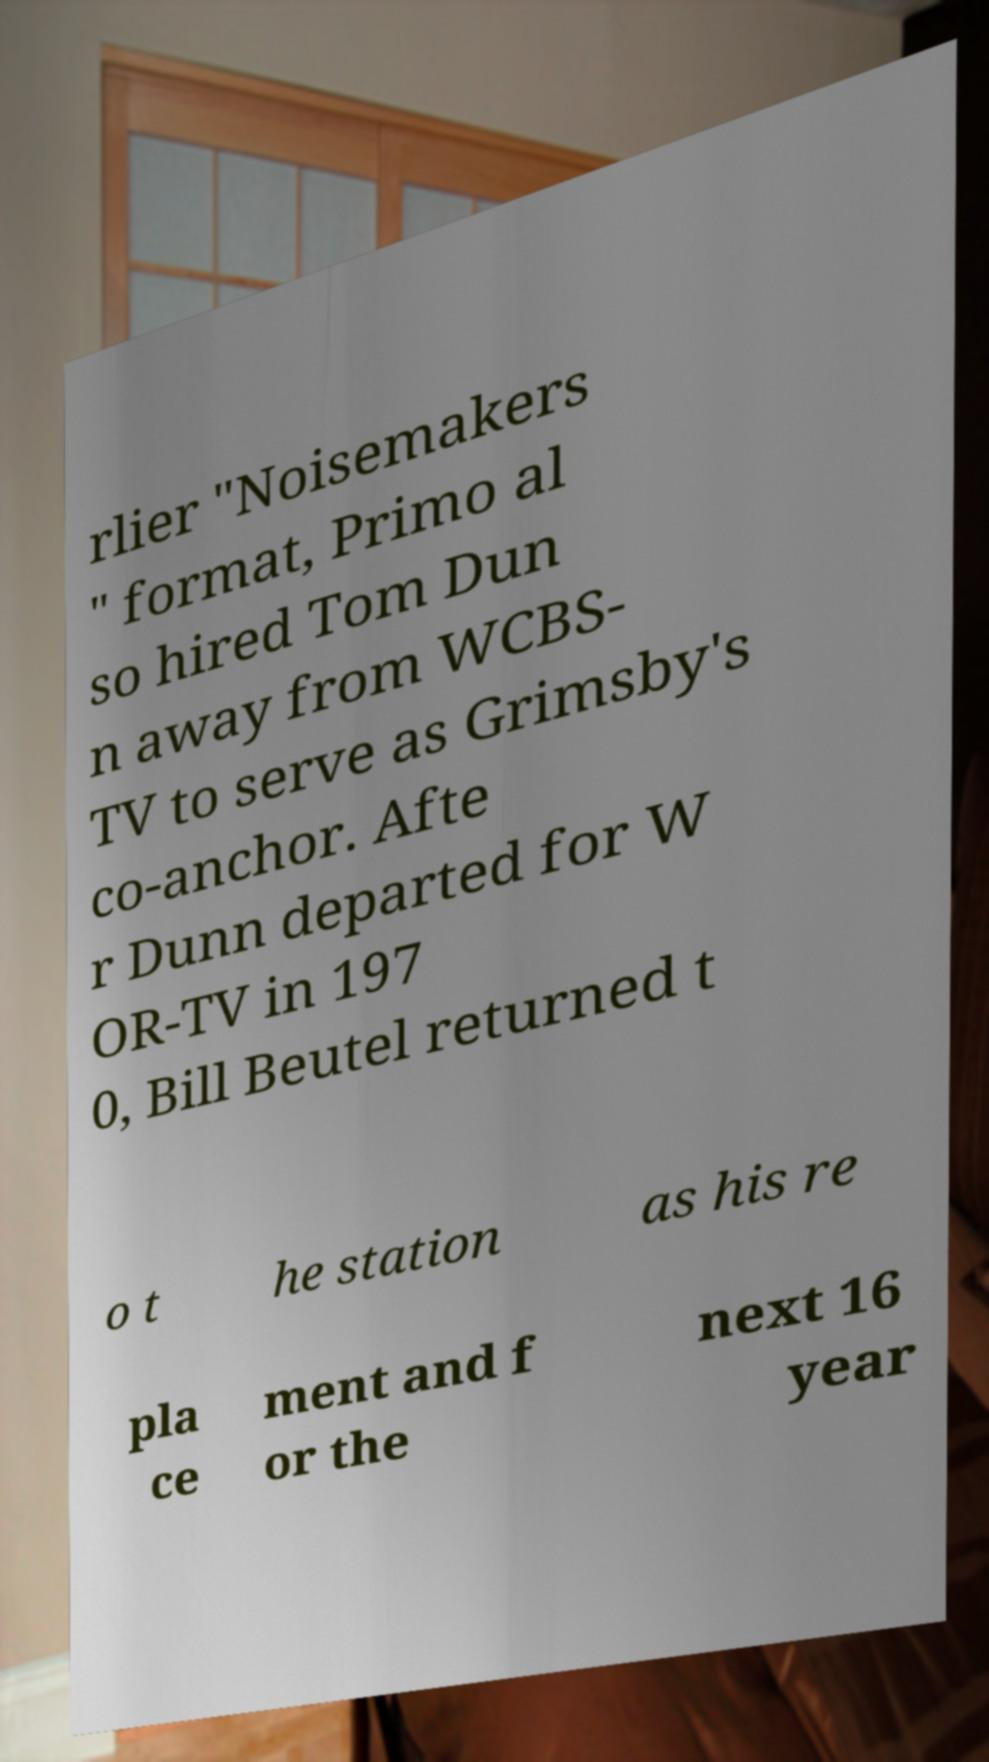For documentation purposes, I need the text within this image transcribed. Could you provide that? rlier "Noisemakers " format, Primo al so hired Tom Dun n away from WCBS- TV to serve as Grimsby's co-anchor. Afte r Dunn departed for W OR-TV in 197 0, Bill Beutel returned t o t he station as his re pla ce ment and f or the next 16 year 